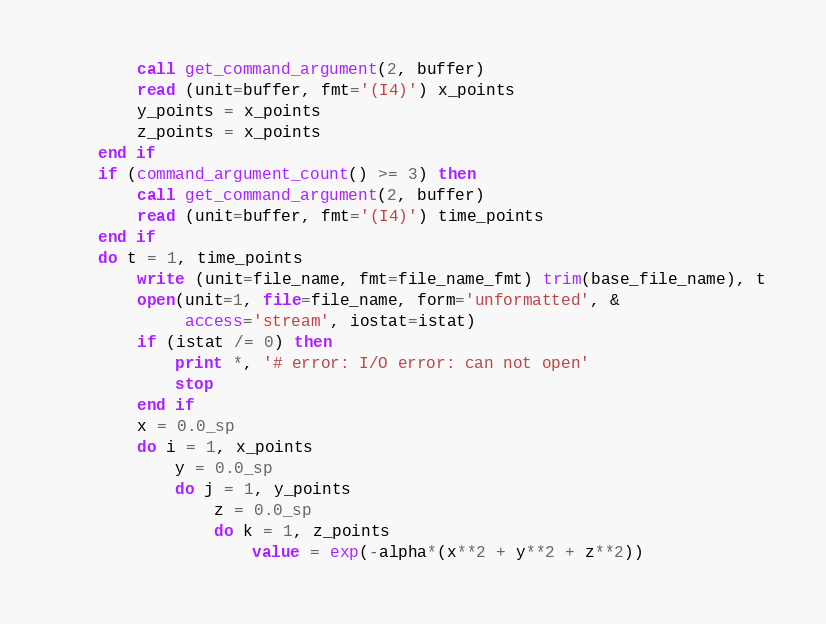Convert code to text. <code><loc_0><loc_0><loc_500><loc_500><_FORTRAN_>        call get_command_argument(2, buffer)
        read (unit=buffer, fmt='(I4)') x_points
        y_points = x_points
        z_points = x_points
    end if
    if (command_argument_count() >= 3) then
        call get_command_argument(2, buffer)
        read (unit=buffer, fmt='(I4)') time_points
    end if
    do t = 1, time_points
        write (unit=file_name, fmt=file_name_fmt) trim(base_file_name), t
        open(unit=1, file=file_name, form='unformatted', &
             access='stream', iostat=istat)
        if (istat /= 0) then
            print *, '# error: I/O error: can not open'
            stop
        end if
        x = 0.0_sp
        do i = 1, x_points
            y = 0.0_sp
            do j = 1, y_points
                z = 0.0_sp
                do k = 1, z_points
                    value = exp(-alpha*(x**2 + y**2 + z**2))</code> 